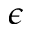Convert formula to latex. <formula><loc_0><loc_0><loc_500><loc_500>\epsilon</formula> 